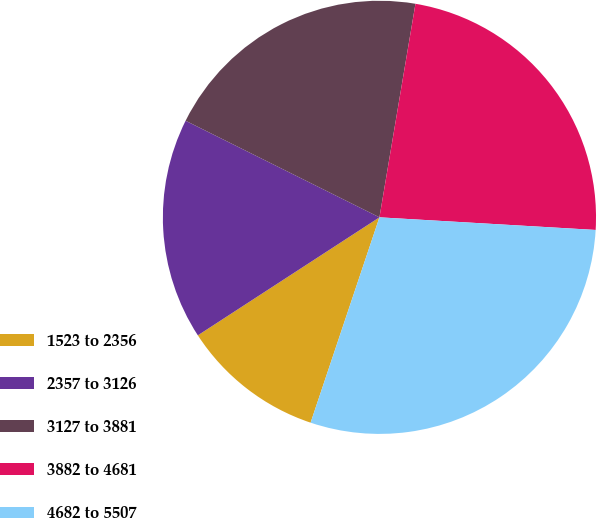Convert chart. <chart><loc_0><loc_0><loc_500><loc_500><pie_chart><fcel>1523 to 2356<fcel>2357 to 3126<fcel>3127 to 3881<fcel>3882 to 4681<fcel>4682 to 5507<nl><fcel>10.68%<fcel>16.53%<fcel>20.3%<fcel>23.27%<fcel>29.22%<nl></chart> 